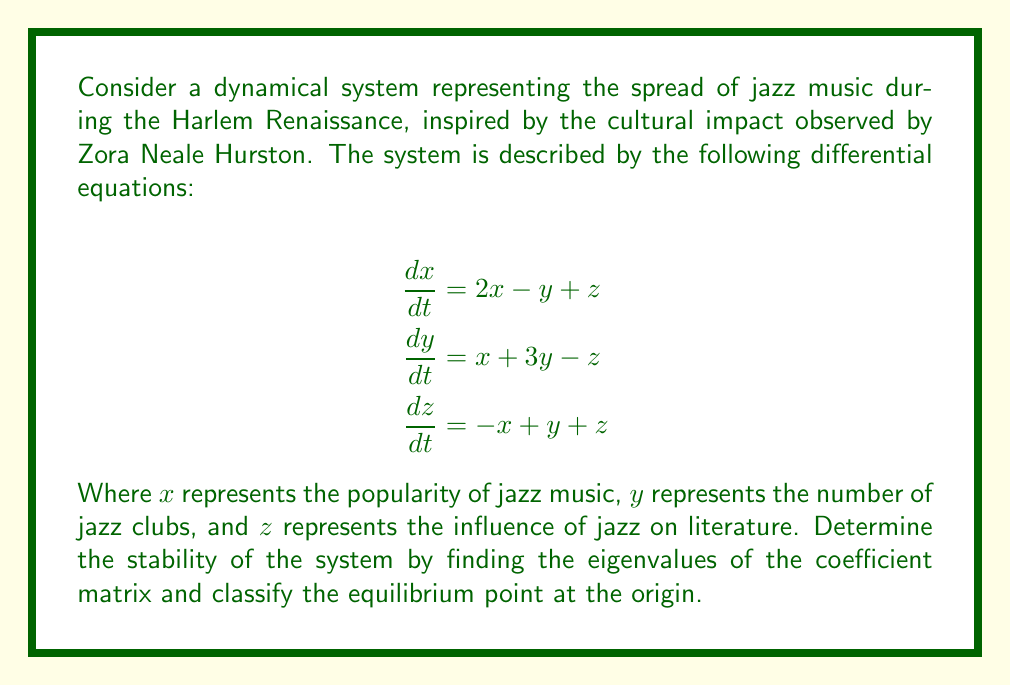Help me with this question. To analyze the stability of this dynamical system, we need to follow these steps:

1. Identify the coefficient matrix A:
   $$A = \begin{bmatrix}
   2 & -1 & 1 \\
   1 & 3 & -1 \\
   -1 & 1 & 1
   \end{bmatrix}$$

2. Calculate the characteristic equation:
   $$\det(A - \lambda I) = 0$$
   
   $$\begin{vmatrix}
   2-\lambda & -1 & 1 \\
   1 & 3-\lambda & -1 \\
   -1 & 1 & 1-\lambda
   \end{vmatrix} = 0$$

3. Expand the determinant:
   $$(2-\lambda)[(3-\lambda)(1-\lambda) + 1] + (-1)[-(1-\lambda) - 1] + 1[1 + (3-\lambda)] = 0$$
   
   $$-\lambda^3 + 6\lambda^2 - 11\lambda + 6 = 0$$

4. Solve for the eigenvalues:
   The characteristic equation is cubic, so we can use the rational root theorem to find one root, then factor the equation.
   
   Potential rational roots: $\pm 1, \pm 2, \pm 3, \pm 6$
   
   By testing, we find that $\lambda = 1$ is a root.
   
   Factoring out $(λ - 1)$:
   $$-(\lambda - 1)(\lambda^2 - 5\lambda + 6) = 0$$
   
   $$-(\lambda - 1)(\lambda - 2)(\lambda - 3) = 0$$

5. The eigenvalues are:
   $$\lambda_1 = 1, \lambda_2 = 2, \lambda_3 = 3$$

6. Classify the equilibrium point:
   Since all eigenvalues are real and positive, the equilibrium point at the origin is an unstable node.
Answer: The system has eigenvalues $\lambda_1 = 1$, $\lambda_2 = 2$, and $\lambda_3 = 3$. The equilibrium point at the origin is an unstable node. 